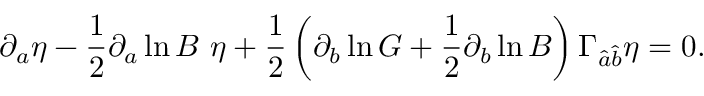Convert formula to latex. <formula><loc_0><loc_0><loc_500><loc_500>\partial _ { a } \eta - { \frac { 1 } { 2 } } \partial _ { a } \ln B \ \eta + { \frac { 1 } { 2 } } \left ( \partial _ { b } \ln G + { \frac { 1 } { 2 } } \partial _ { b } \ln B \right ) \Gamma _ { \hat { a } \hat { b } } \eta = 0 .</formula> 